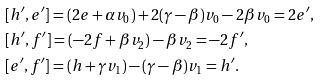Convert formula to latex. <formula><loc_0><loc_0><loc_500><loc_500>& [ h ^ { \prime } , e ^ { \prime } ] = ( 2 e + \alpha v _ { 0 } ) + 2 ( \gamma - \beta ) v _ { 0 } - 2 \beta v _ { 0 } = 2 e ^ { \prime } , \\ & [ h ^ { \prime } , f ^ { \prime } ] = ( - 2 f + \beta v _ { 2 } ) - \beta v _ { 2 } = - 2 f ^ { \prime } , \\ & [ e ^ { \prime } , f ^ { \prime } ] = ( h + \gamma v _ { 1 } ) - ( \gamma - \beta ) v _ { 1 } = h ^ { \prime } .</formula> 